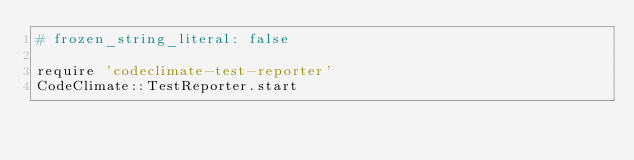Convert code to text. <code><loc_0><loc_0><loc_500><loc_500><_Ruby_># frozen_string_literal: false

require 'codeclimate-test-reporter'
CodeClimate::TestReporter.start
</code> 